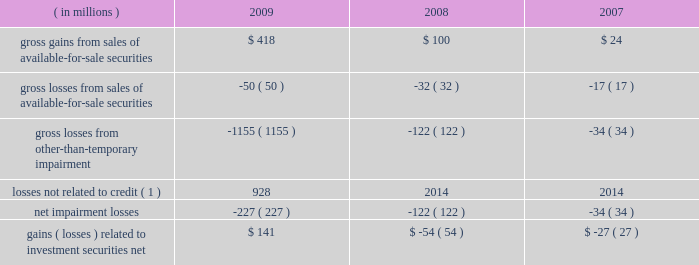In connection with our assessment of impairment we recorded gross other-than-temporary impairment of $ 1.15 billion for 2009 , compared to $ 122 million for 2008 .
Of the total recorded , $ 227 million related to credit and was recognized in our consolidated statement of income .
The remaining $ 928 million related to factors other than credit , more fully discussed below , and was recognized , net of related taxes , in oci in our consolidated statement of condition .
The $ 227 million was composed of $ 151 million associated with expected credit losses , $ 54 million related to management 2019s decision to sell the impaired securities prior to their recovery in value , and $ 22 million related to adverse changes in the timing of expected future cash flows from the securities .
The majority of the impairment losses related to non-agency securities collateralized by mortgages , for which management concluded had experienced credit losses based on the present value of the securities 2019 expected future cash flows .
These securities are classified as asset-backed securities in the foregoing investment securities tables .
As described in note 1 , management periodically reviews the fair values of investment securities to determine if other-than-temporary impairment has occurred .
This review encompasses all investment securities and includes such quantitative factors as current and expected future interest rates and the length of time that a security 2019s cost basis has exceeded its fair value , and includes investment securities for which we have issuer- specific concerns regardless of quantitative factors .
Gains and losses related to investment securities were as follows for the years ended december 31: .
( 1 ) these losses were recognized as a component of oci ; see note 12 .
We conduct periodic reviews to evaluate each security that is impaired .
Impairment exists when the current fair value of an individual security is below its amortized cost basis .
For debt securities available for sale and held to maturity , other-than-temporary impairment is recorded in our consolidated statement of income when management intends to sell ( or may be required to sell ) securities before they recover in value , or when management expects the present value of cash flows expected to be collected to be less than the amortized cost of the impaired security ( a credit loss ) .
Our review of impaired securities generally includes : 2022 the identification and evaluation of securities that have indications of possible other-than-temporary impairment , such as issuer-specific concerns including deteriorating financial condition or bankruptcy ; 2022 the analysis of expected future cash flows of securities , based on quantitative and qualitative factors ; 2022 the analysis of the collectability of those future cash flows , including information about past events , current conditions and reasonable and supportable forecasts ; 2022 the analysis of individual impaired securities , including consideration of the length of time the security has been in an unrealized loss position and the anticipated recovery period ; 2022 the discussion of evidential matter , including an evaluation of factors or triggers that could cause individual securities to be deemed other-than-temporarily impaired and those that would not support other-than-temporary impairment ; and 2022 documentation of the results of these analyses .
Factors considered in determining whether impairment is other than temporary include : 2022 the length of time the security has been impaired; .
What was the average gross gains from sales of available-for-sale securities from 2007 to 2009? 
Computations: ((((418 + 100) + 24) + 3) / 2)
Answer: 272.5. 